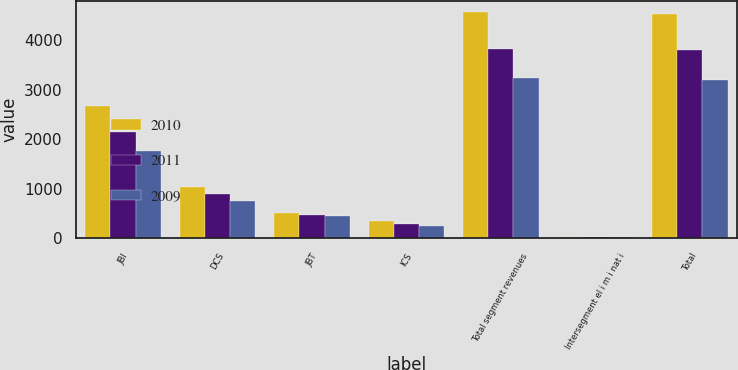Convert chart. <chart><loc_0><loc_0><loc_500><loc_500><stacked_bar_chart><ecel><fcel>JBI<fcel>DCS<fcel>JBT<fcel>ICS<fcel>Total segment revenues<fcel>Intersegment el i m i nat i<fcel>Total<nl><fcel>2010<fcel>2673<fcel>1031<fcel>504<fcel>356<fcel>4564<fcel>37<fcel>4527<nl><fcel>2011<fcel>2141<fcel>907<fcel>479<fcel>291<fcel>3818<fcel>25<fcel>3793<nl><fcel>2009<fcel>1764<fcel>757<fcel>447<fcel>259<fcel>3227<fcel>24<fcel>3203<nl></chart> 